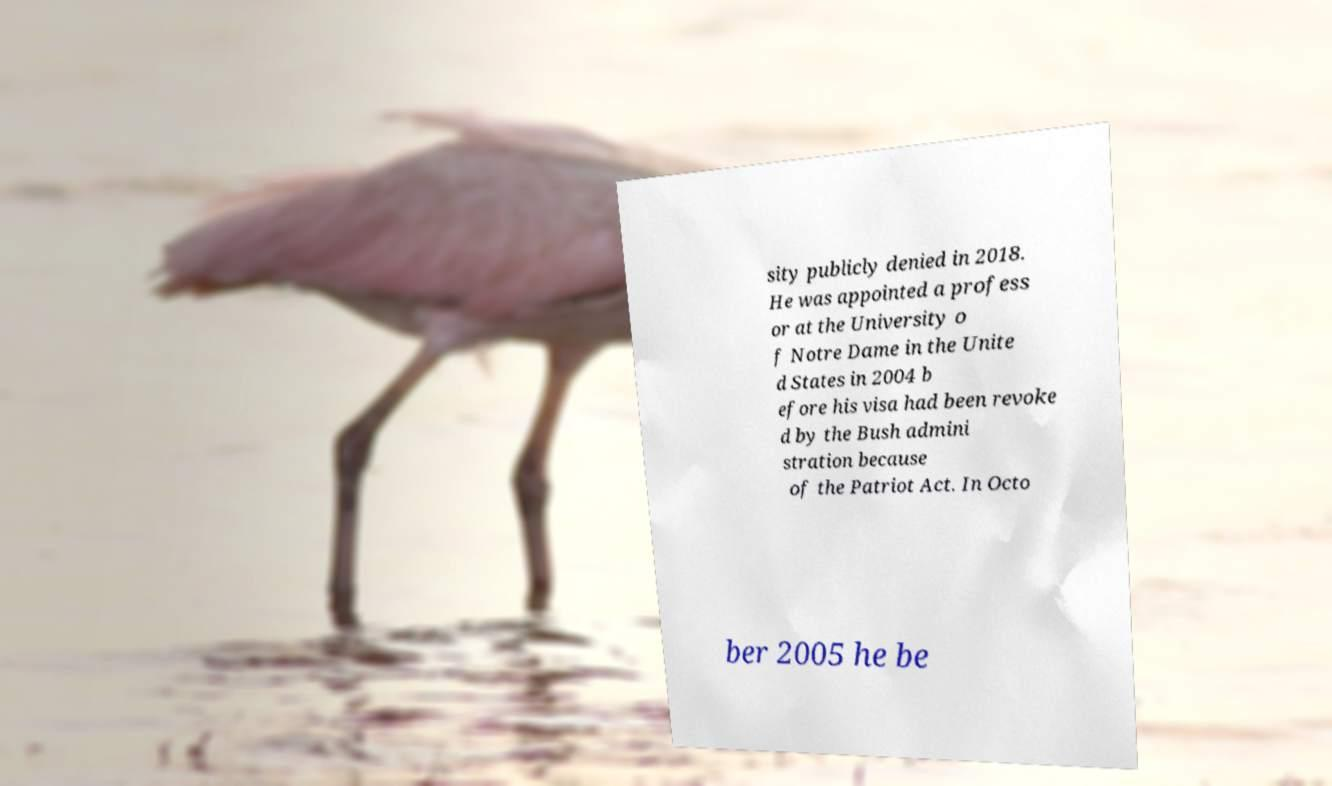I need the written content from this picture converted into text. Can you do that? sity publicly denied in 2018. He was appointed a profess or at the University o f Notre Dame in the Unite d States in 2004 b efore his visa had been revoke d by the Bush admini stration because of the Patriot Act. In Octo ber 2005 he be 